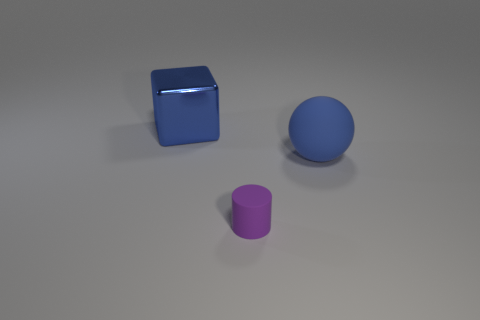Do the blue object in front of the blue shiny block and the rubber object in front of the large matte thing have the same size?
Make the answer very short. No. What is the color of the ball that is the same material as the small purple cylinder?
Provide a succinct answer. Blue. Is the big object that is on the right side of the tiny purple matte object made of the same material as the large thing on the left side of the small purple matte cylinder?
Provide a short and direct response. No. Is there a ball of the same size as the blue cube?
Provide a short and direct response. Yes. How big is the thing in front of the blue object on the right side of the block?
Provide a succinct answer. Small. What number of small matte cylinders have the same color as the large matte ball?
Your answer should be compact. 0. There is a rubber thing left of the large object in front of the block; what is its shape?
Provide a short and direct response. Cylinder. What number of things are the same material as the big ball?
Keep it short and to the point. 1. There is a big thing that is in front of the big blue metal cube; what is it made of?
Keep it short and to the point. Rubber. What shape is the large object to the left of the large blue object on the right side of the rubber object that is in front of the big blue ball?
Your answer should be very brief. Cube. 